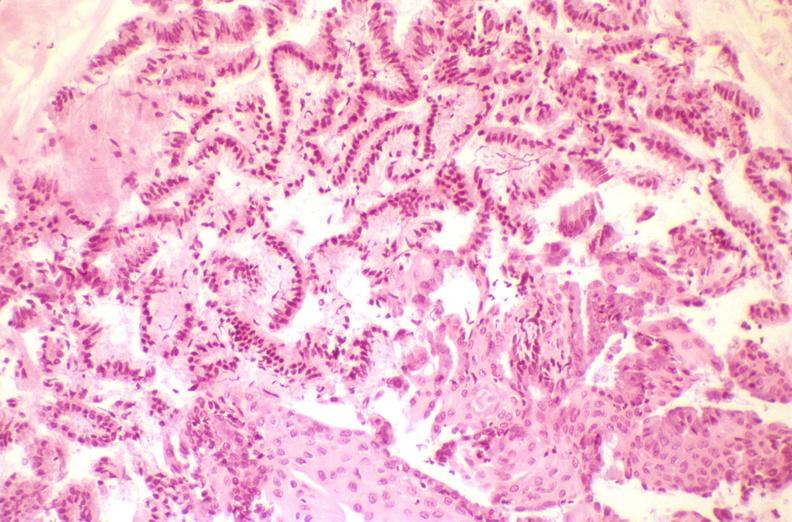s female reproductive present?
Answer the question using a single word or phrase. Yes 